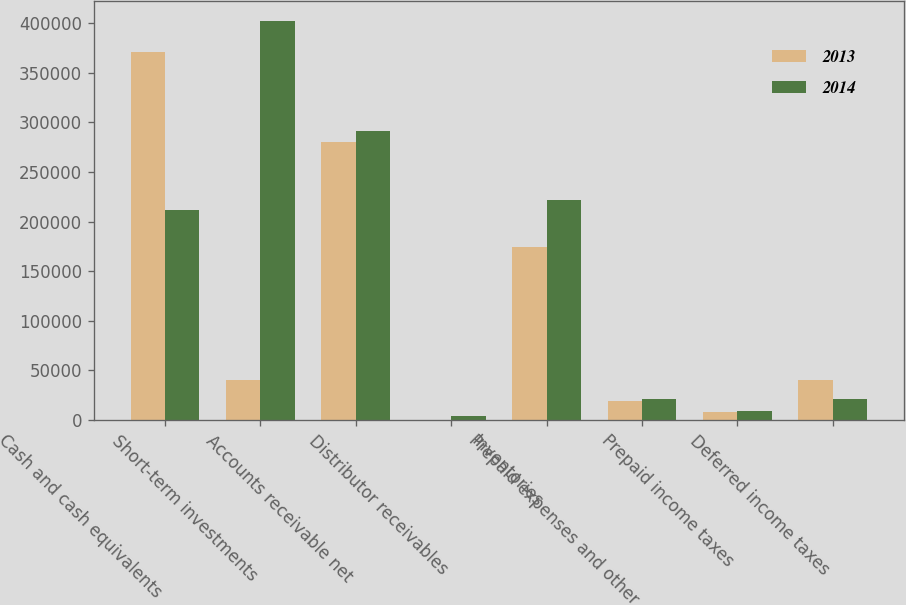Convert chart. <chart><loc_0><loc_0><loc_500><loc_500><stacked_bar_chart><ecel><fcel>Cash and cash equivalents<fcel>Short-term investments<fcel>Accounts receivable net<fcel>Distributor receivables<fcel>Inventories<fcel>Prepaid expenses and other<fcel>Prepaid income taxes<fcel>Deferred income taxes<nl><fcel>2013<fcel>370323<fcel>40275<fcel>280203<fcel>552<fcel>174573<fcel>19673<fcel>8617<fcel>40275<nl><fcel>2014<fcel>211349<fcel>402247<fcel>291638<fcel>4542<fcel>221449<fcel>21376<fcel>9518<fcel>20924<nl></chart> 